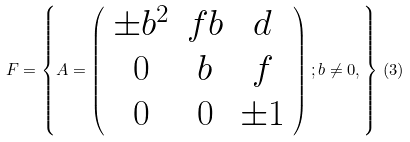<formula> <loc_0><loc_0><loc_500><loc_500>F = \left \{ A = \left ( \begin{array} { c c c } \pm b ^ { 2 } & f b & d \\ 0 & b & f \\ 0 & 0 & \pm 1 \\ \end{array} \right ) ; b \neq 0 , \right \} \, ( 3 )</formula> 